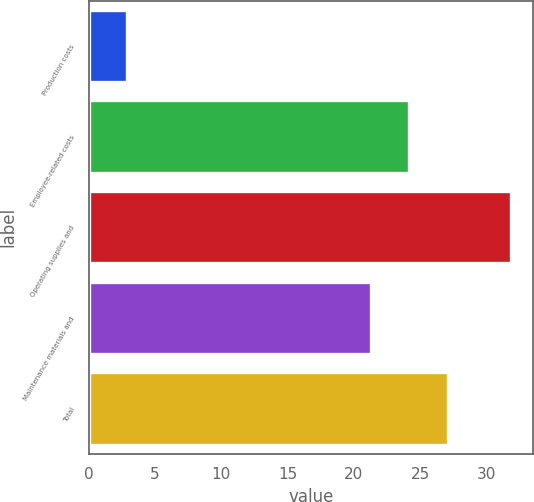Convert chart to OTSL. <chart><loc_0><loc_0><loc_500><loc_500><bar_chart><fcel>Production costs<fcel>Employee-related costs<fcel>Operating supplies and<fcel>Maintenance materials and<fcel>Total<nl><fcel>2.9<fcel>24.2<fcel>31.9<fcel>21.3<fcel>27.1<nl></chart> 